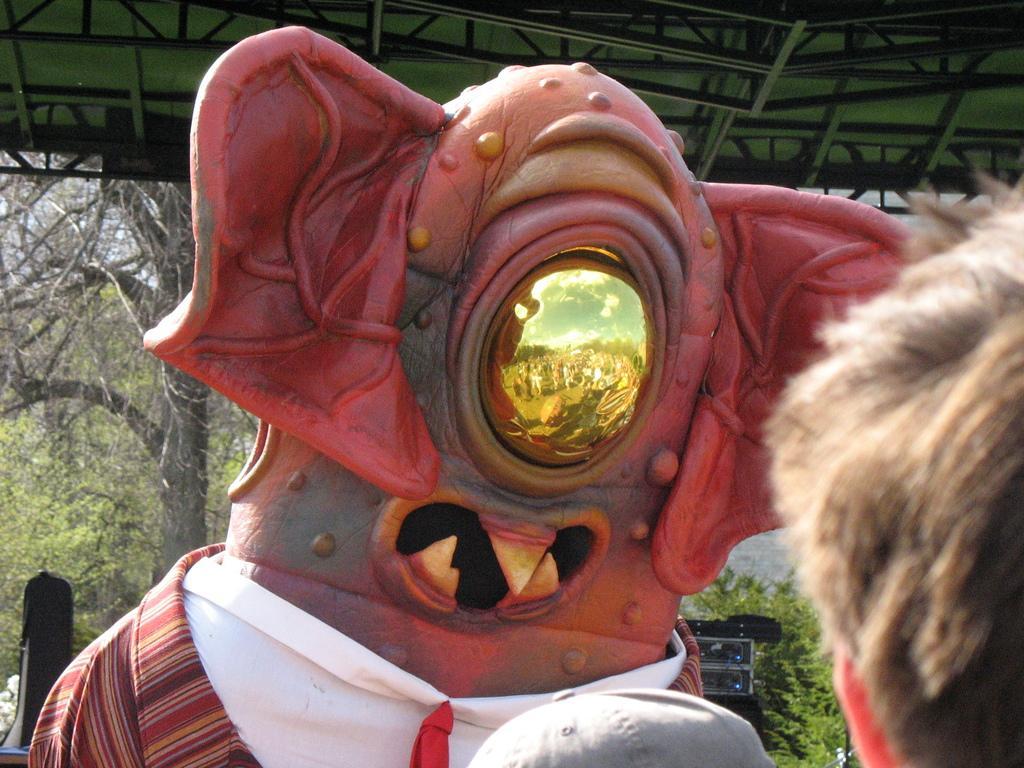Please provide a concise description of this image. In this image I see the depiction of an alien and I see the clothing on it and I see a person's head over here and I see the cap over here. In the background I see the trees and the shed. 